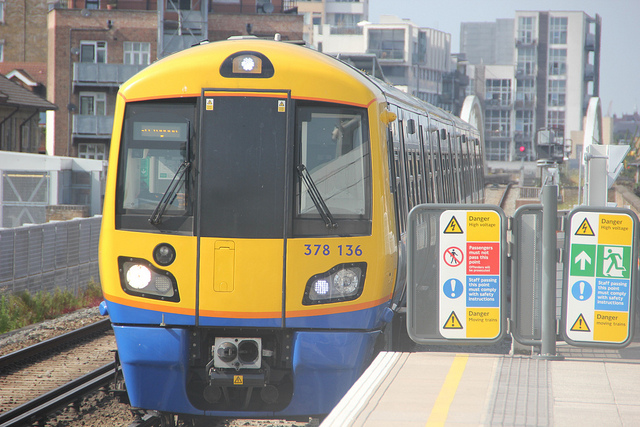Please identify all text content in this image. 136 378 Danger Danger 